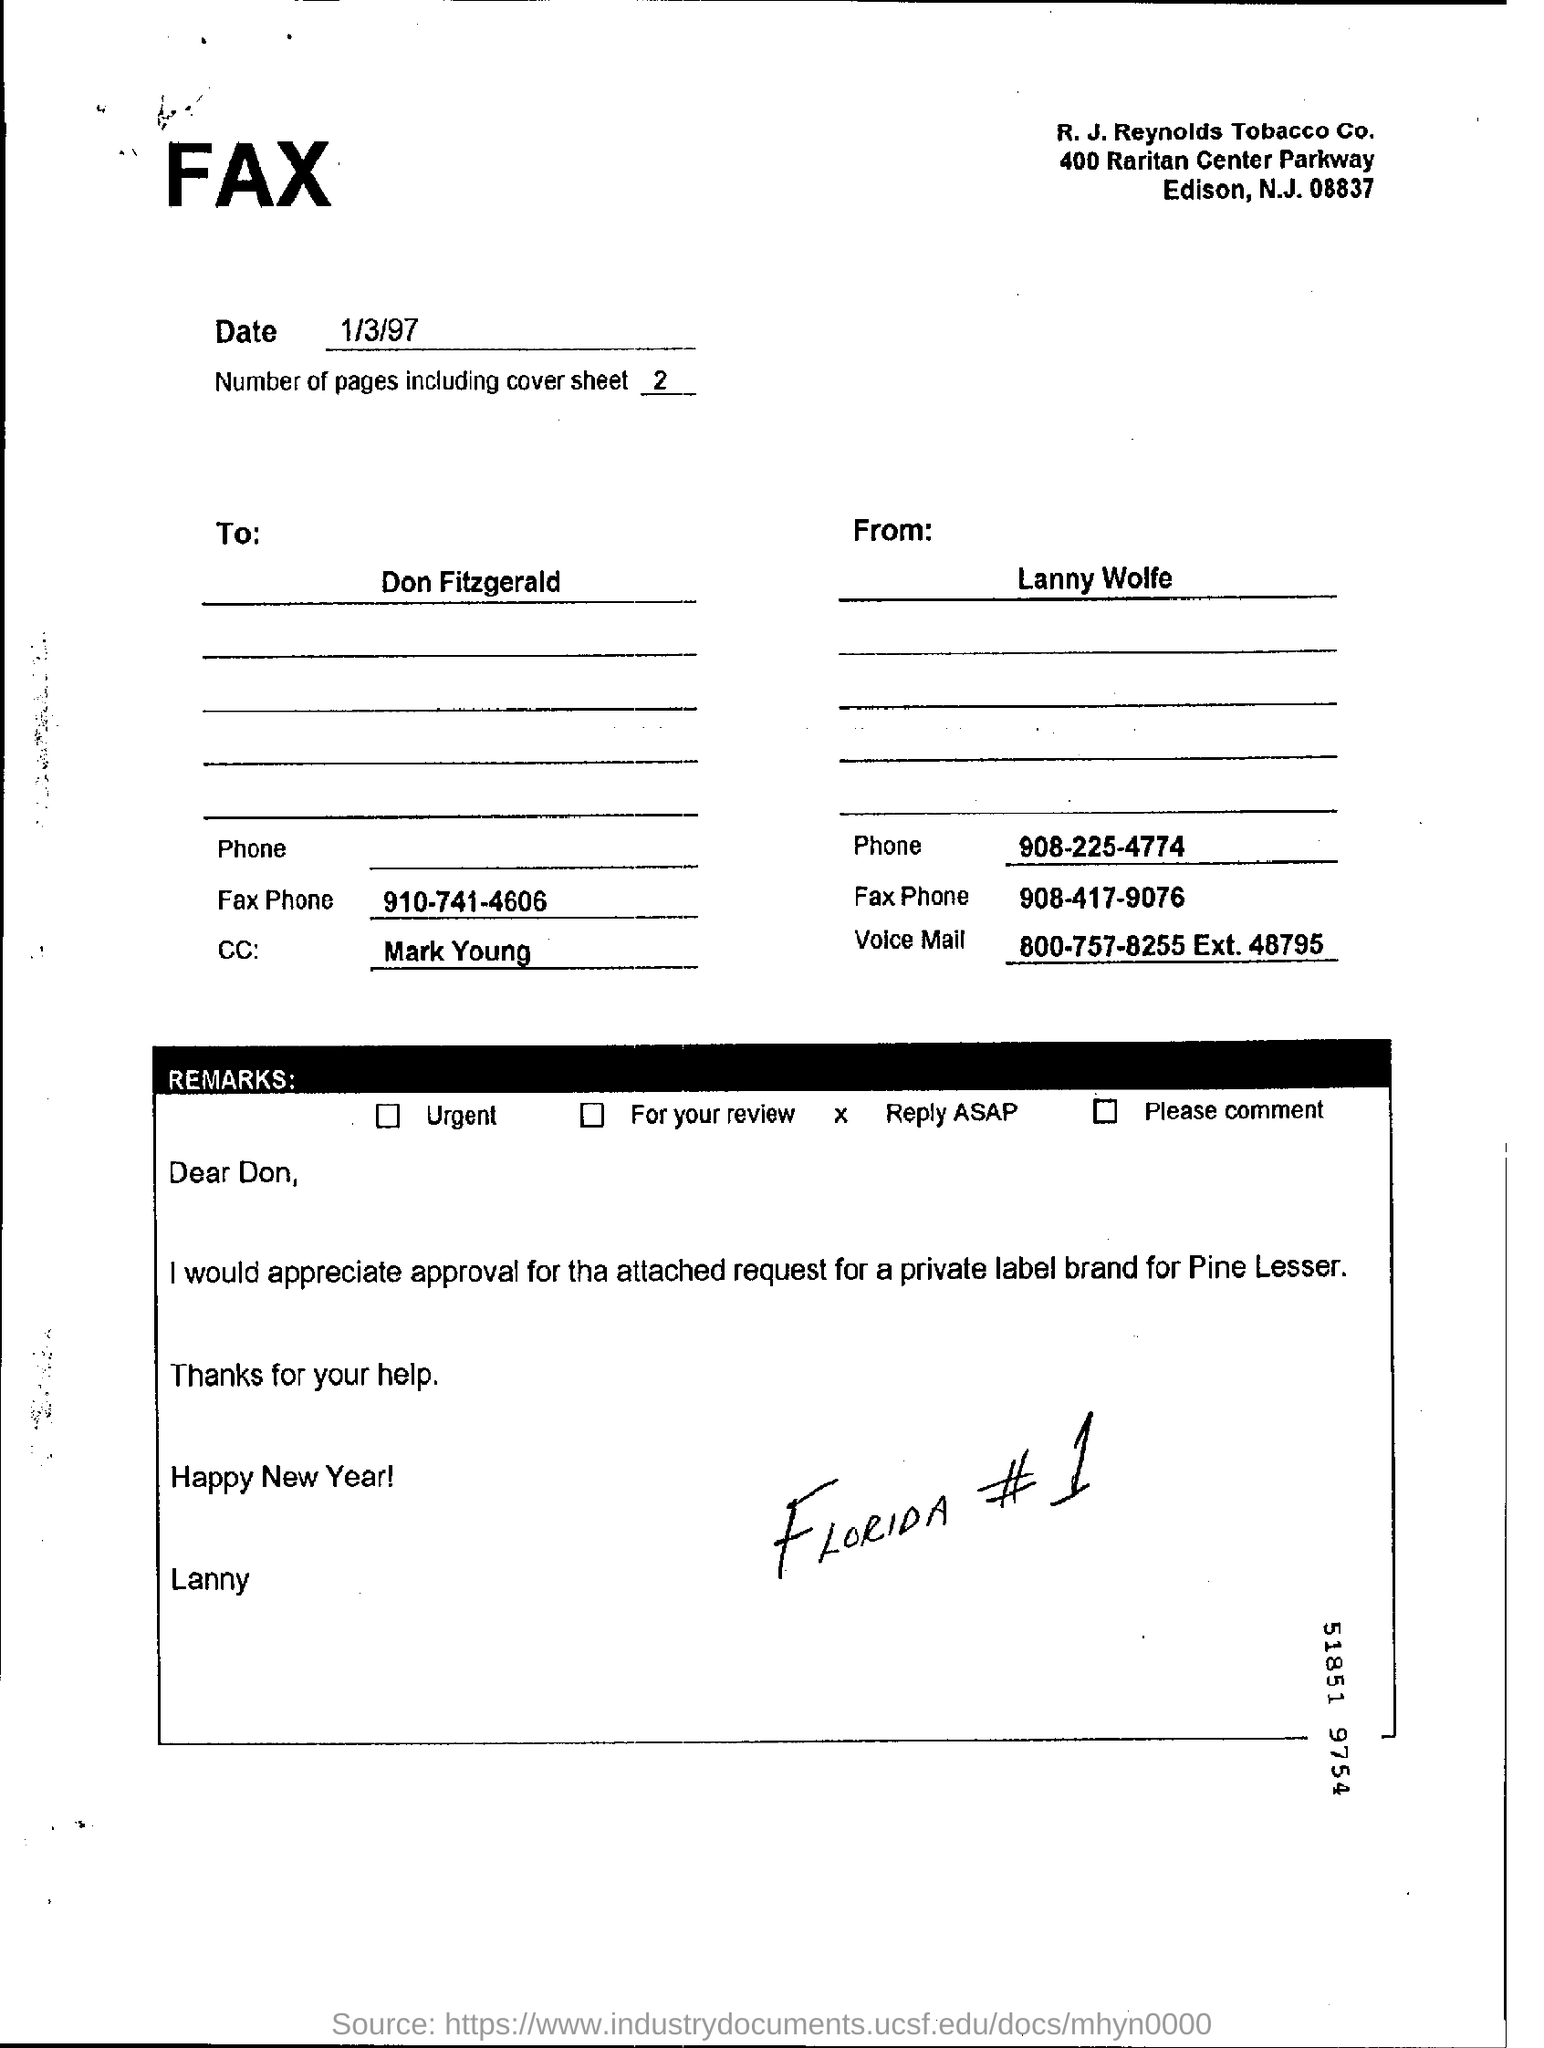What is the date of the fax ?
Provide a short and direct response. 1/3/97. Number of pages including cover sheet ?
Your answer should be very brief. 2. To whom the fax is send ?
Provide a short and direct response. Don fitzgerald. Who is sending the fax ?
Offer a very short reply. Lanny wolfe . 